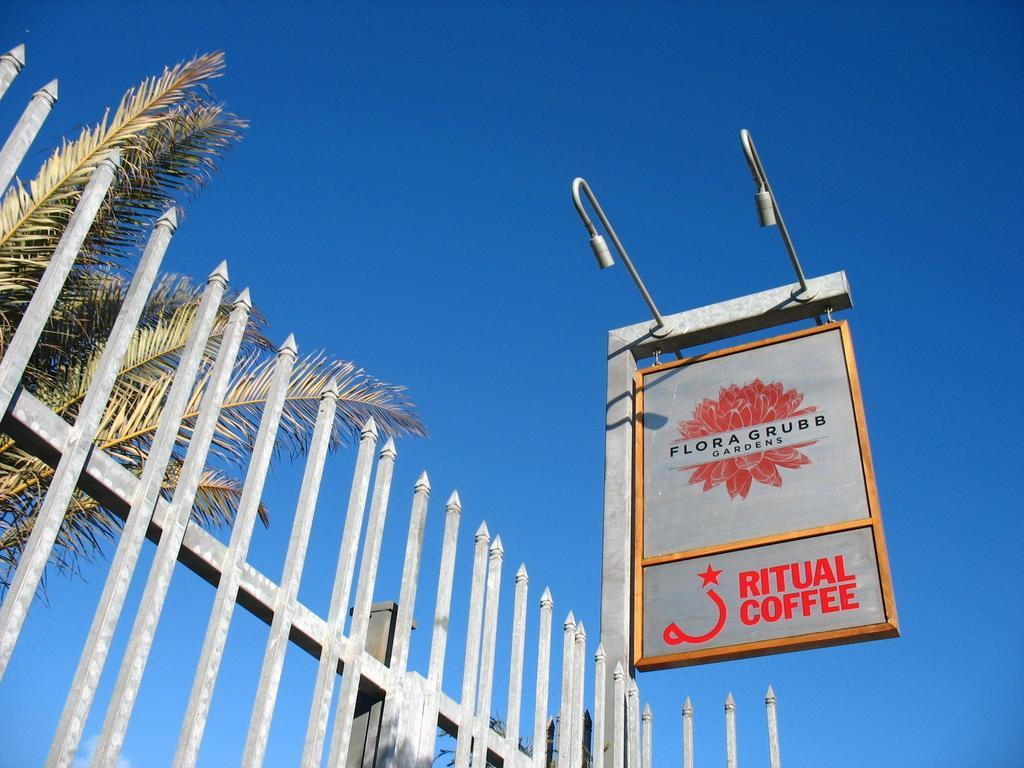What is the main object in the image? There is an advertisement board in the image. What other objects can be seen in the image? There are street lights and a grill visible in the image. What can be seen in the background of the image? There are trees and the sky visible in the background of the image. How many yams are being pushed in the image? There are no yams or pushing activity present in the image. 